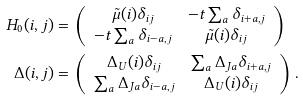Convert formula to latex. <formula><loc_0><loc_0><loc_500><loc_500>H _ { 0 } ( { i , j } ) & = \left ( \begin{array} { c c } \tilde { \mu } ( { i } ) \delta _ { i j } & - t \sum _ { a } \delta _ { i + a , j } \\ - t \sum _ { a } \delta _ { i - a , j } & \tilde { \mu } ( { i } ) \delta _ { i j } \end{array} \right ) \\ \Delta ( { i , j } ) & = \left ( \begin{array} { c c } \Delta _ { U } ( { i } ) \delta _ { i j } & \sum _ { a } \Delta _ { J { a } } \delta _ { i + a , j } \\ \sum _ { a } \Delta _ { J { a } } \delta _ { i - a , j } & \Delta _ { U } ( { i } ) \delta _ { i j } \end{array} \right ) .</formula> 